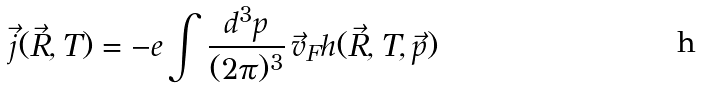<formula> <loc_0><loc_0><loc_500><loc_500>\vec { j } ( \vec { R } , T ) = - e \int \frac { d ^ { 3 } p } { ( 2 \pi ) ^ { 3 } } \, \vec { v } _ { F } h ( \vec { R } , T , \vec { p } )</formula> 